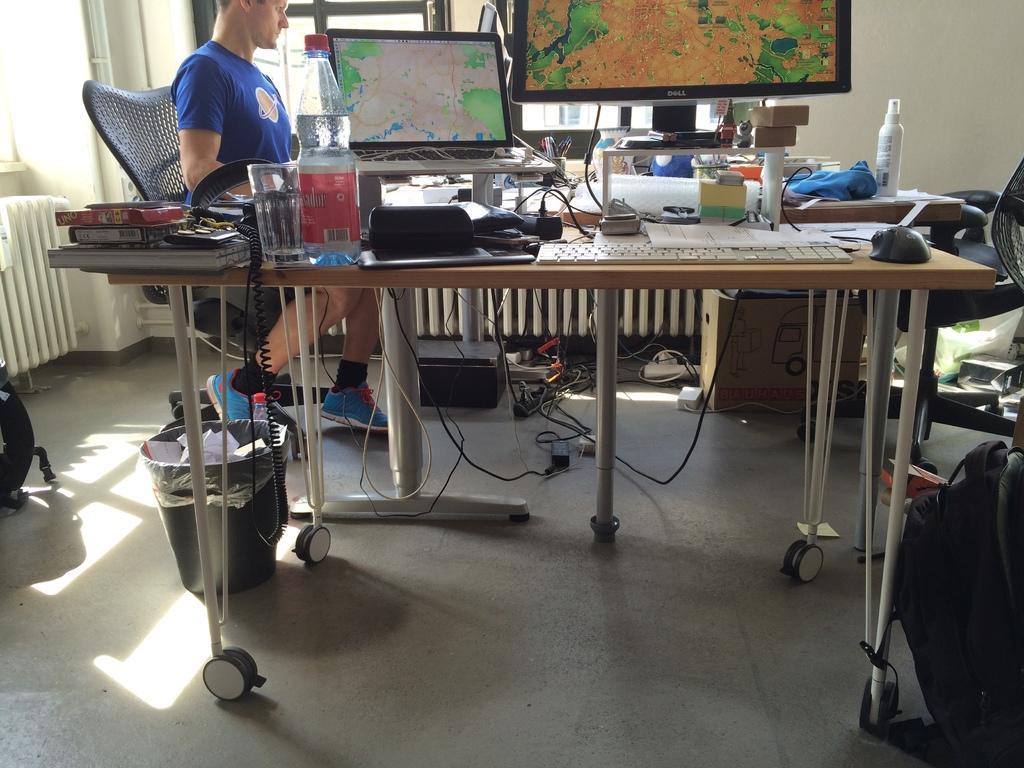How would you summarize this image in a sentence or two? On the background we can see window, wall. We can see a person sitting on a chair in front of a table and on the table we can see glass of water, water bottle, computer, keyboard , boxes, bottles, mouse. We can see trash can under the table. This is a backpack beside the table. This is a floor. 